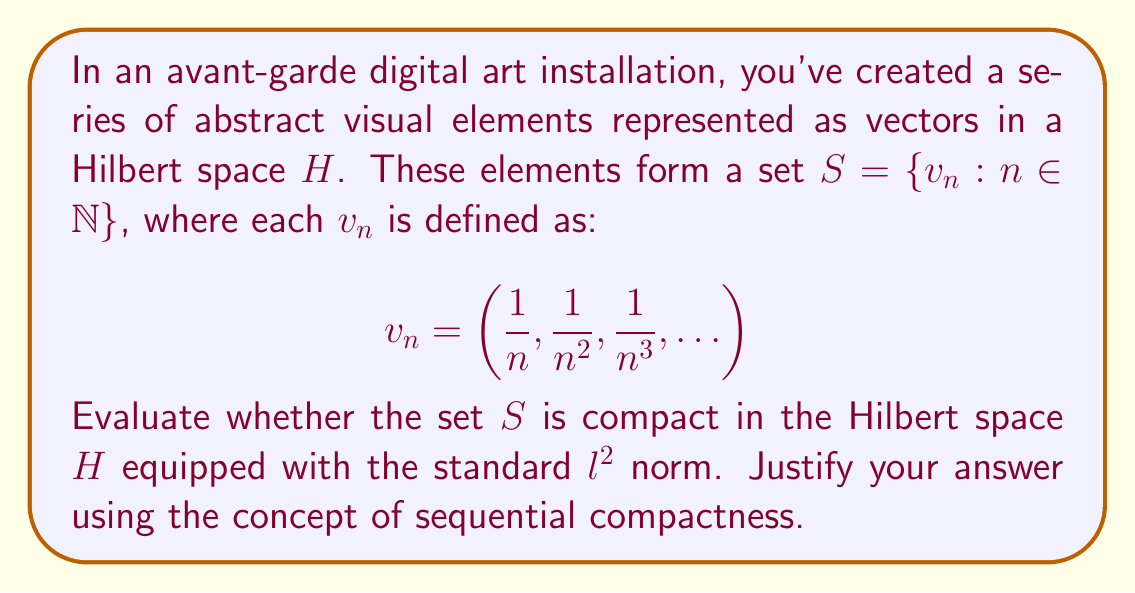Help me with this question. To evaluate the compactness of set $S$ in the Hilbert space $H$, we'll use the following approach:

1) First, recall that in a metric space (including Hilbert spaces), compactness is equivalent to sequential compactness. A set is sequentially compact if every sequence in the set has a convergent subsequence with a limit in the set.

2) Let's consider an arbitrary sequence $(v_{n_k})_{k=1}^{\infty}$ in $S$. We need to determine if it has a convergent subsequence.

3) Observe that for any $v_n \in S$:

   $$\|v_n\|^2 = \sum_{i=1}^{\infty} \frac{1}{n^{2i}} = \frac{1}{n^2} + \frac{1}{n^4} + \frac{1}{n^6} + \ldots = \frac{1/n^2}{1-1/n^2} = \frac{1}{n^2-1}$$

4) As $n \to \infty$, $\|v_n\| \to 0$. This suggests that the zero vector might be a limit point of $S$.

5) Now, for any $\epsilon > 0$, we can find $N \in \mathbb{N}$ such that for all $n > N$, $\|v_n\| < \epsilon$.

6) This means that for any sequence $(v_{n_k})_{k=1}^{\infty}$ in $S$, we can find a subsequence that converges to the zero vector.

7) However, the zero vector is not in $S$, as each element of $S$ has a non-zero first component.

8) Therefore, while $S$ has a limit point (the zero vector), this limit point is not in $S$. This means $S$ is not closed.

9) In a metric space, a set is compact if and only if it is closed and bounded. We've shown that $S$ is not closed, so it cannot be compact.
Answer: The set $S$ is not compact in the Hilbert space $H$. While $S$ is bounded (as $\|v_n\| < 1$ for all $n$), it is not closed because it does not contain its limit point (the zero vector). Therefore, $S$ fails to meet the necessary conditions for compactness in a metric space. 